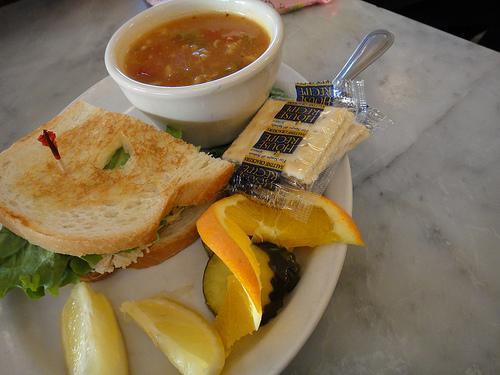How many people are in the photo?
Give a very brief answer. 0. How many pieces of citrus fruit on the plate are cut into wedges?
Give a very brief answer. 2. 